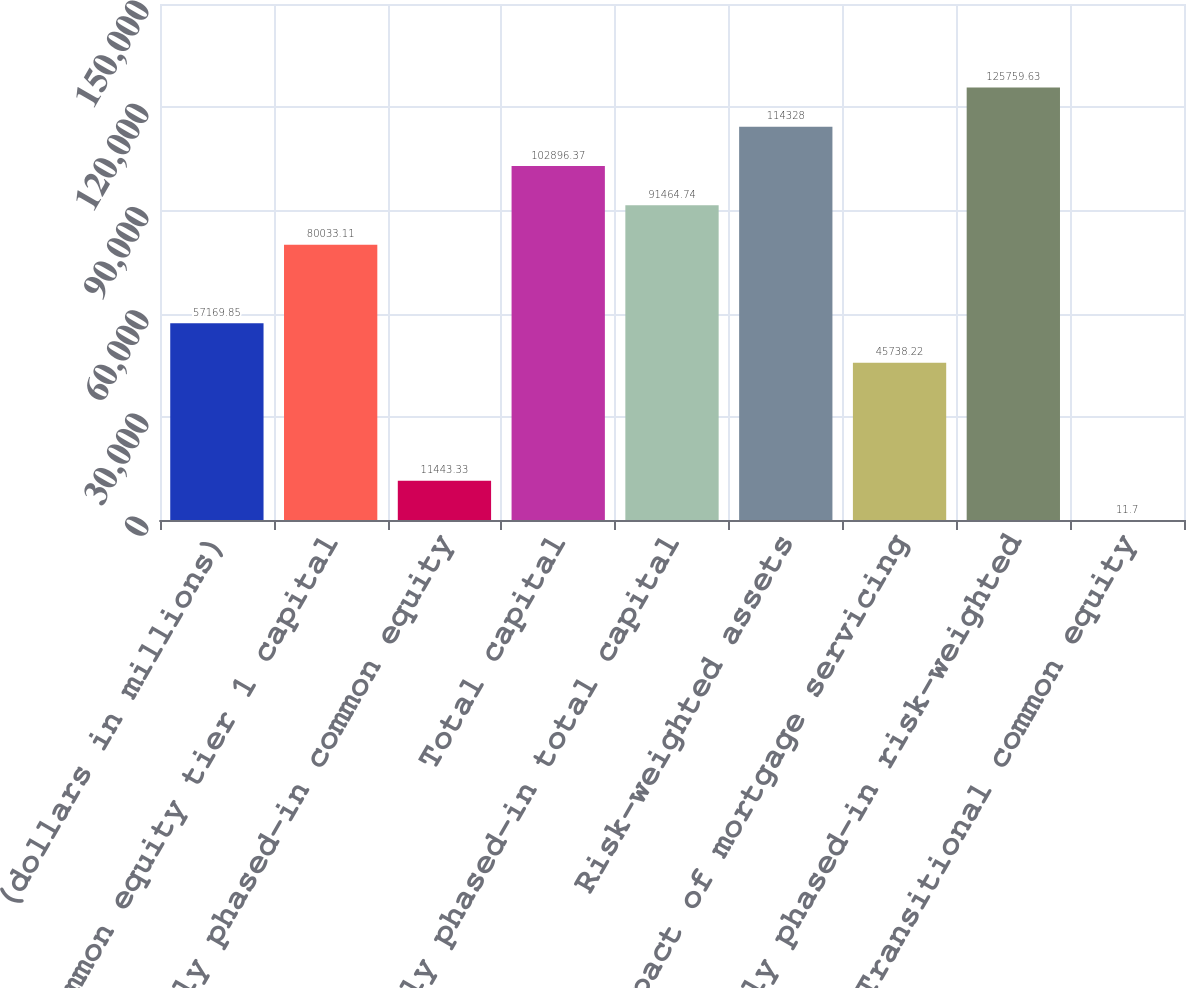<chart> <loc_0><loc_0><loc_500><loc_500><bar_chart><fcel>(dollars in millions)<fcel>Common equity tier 1 capital<fcel>Fully phased-in common equity<fcel>Total capital<fcel>Fully phased-in total capital<fcel>Risk-weighted assets<fcel>Impact of mortgage servicing<fcel>Fully phased-in risk-weighted<fcel>Transitional common equity<nl><fcel>57169.8<fcel>80033.1<fcel>11443.3<fcel>102896<fcel>91464.7<fcel>114328<fcel>45738.2<fcel>125760<fcel>11.7<nl></chart> 